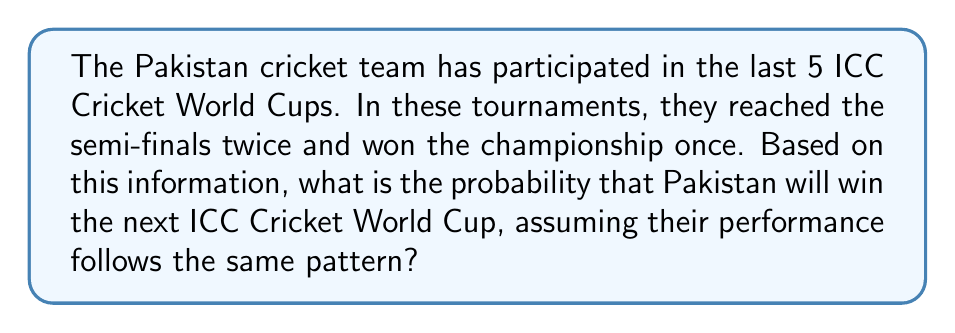What is the answer to this math problem? Let's approach this step-by-step:

1) First, we need to calculate the probability of Pakistan winning a World Cup based on their past performance.

2) In the last 5 World Cups:
   - They won 1 time
   - Total number of tournaments = 5

3) The probability of winning can be calculated as:

   $$P(\text{winning}) = \frac{\text{Number of wins}}{\text{Total number of tournaments}}$$

4) Substituting the values:

   $$P(\text{winning}) = \frac{1}{5} = 0.2$$

5) This means that based on their past performance, Pakistan has a 20% chance of winning any given World Cup.

6) Assuming their performance follows the same pattern, this probability would apply to the next World Cup as well.

7) Therefore, the probability of Pakistan winning the next ICC Cricket World Cup is 0.2 or 20%.
Answer: $0.2$ or $20\%$ 